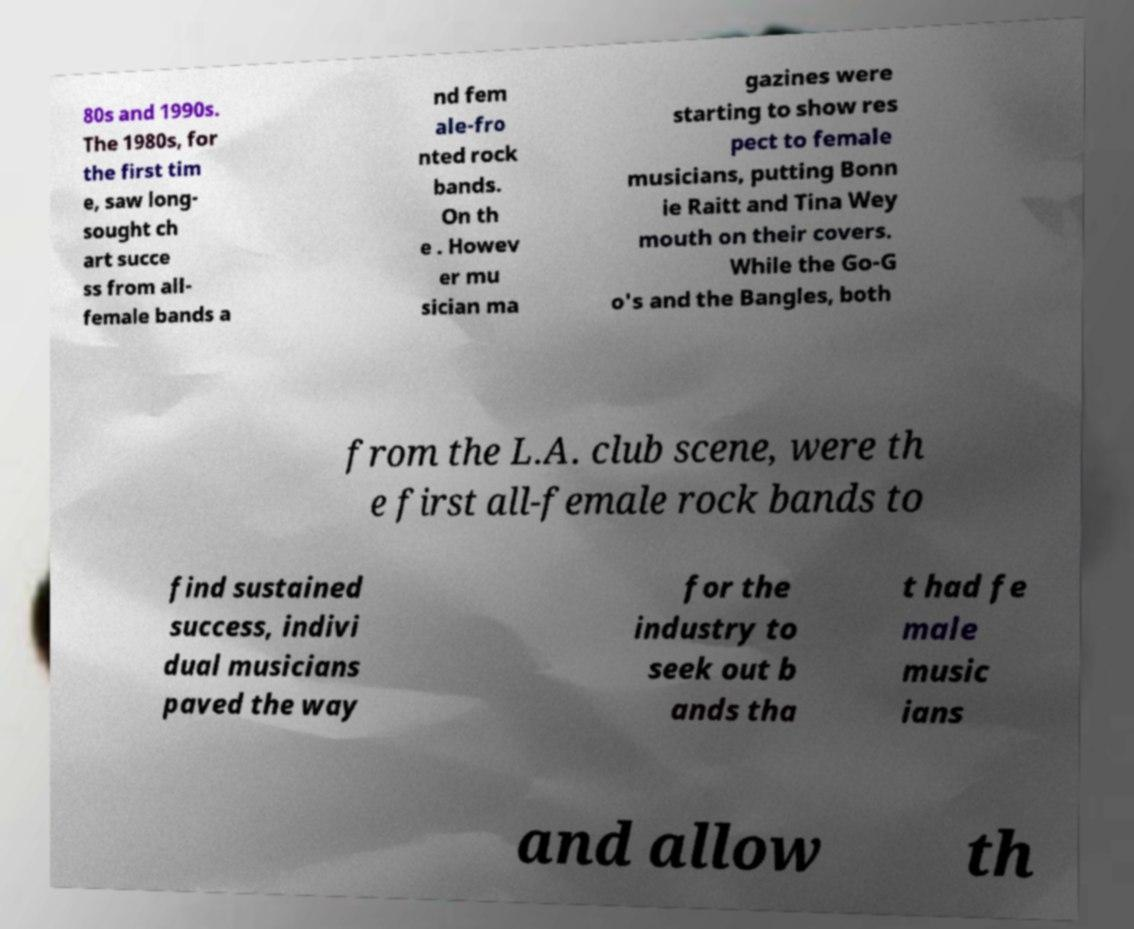Can you read and provide the text displayed in the image?This photo seems to have some interesting text. Can you extract and type it out for me? 80s and 1990s. The 1980s, for the first tim e, saw long- sought ch art succe ss from all- female bands a nd fem ale-fro nted rock bands. On th e . Howev er mu sician ma gazines were starting to show res pect to female musicians, putting Bonn ie Raitt and Tina Wey mouth on their covers. While the Go-G o's and the Bangles, both from the L.A. club scene, were th e first all-female rock bands to find sustained success, indivi dual musicians paved the way for the industry to seek out b ands tha t had fe male music ians and allow th 